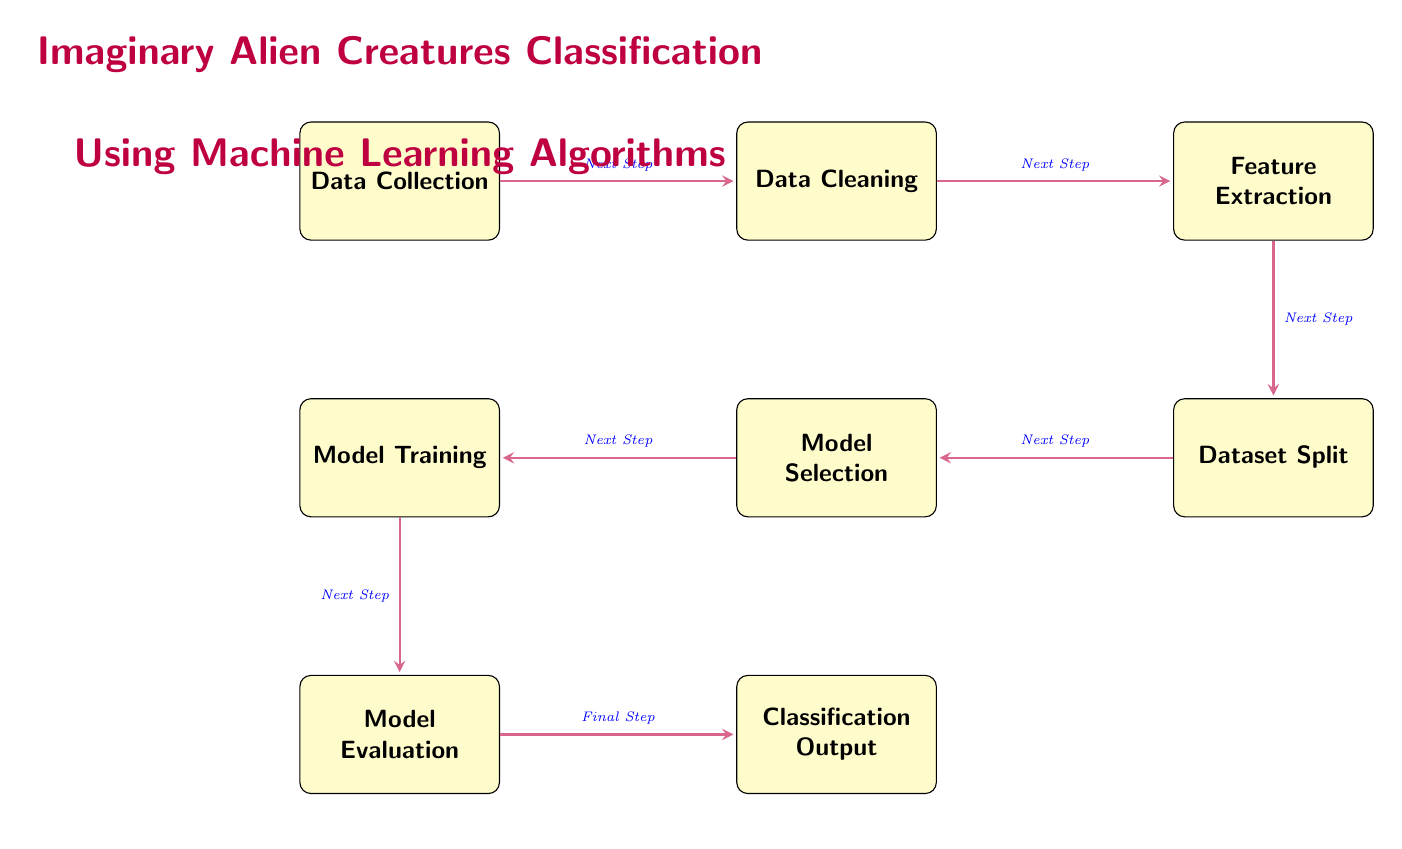What is the first step in the diagram? The first step in the diagram is labeled "Data Collection." It is positioned at the far left and shows the starting point of the process for classifying imaginary alien creatures.
Answer: Data Collection What node follows "Data Cleaning"? The node that follows "Data Cleaning" is "Feature Extraction." From the direction of the arrows in the diagram, it is clear that "Feature Extraction" comes right after "Data Cleaning."
Answer: Feature Extraction How many nodes are in the diagram? To find the number of nodes, we can count them: "Data Collection," "Data Cleaning," "Feature Extraction," "Dataset Split," "Model Selection," "Model Training," "Model Evaluation," and "Classification Output." There are eight nodes in total.
Answer: Eight What is the last step before the "Classification Output"? The last step before "Classification Output" is "Model Evaluation." This is indicated by the arrow leading directly to "Classification Output" from "Model Evaluation," completing the process.
Answer: Model Evaluation What does "Model Selection" involve? "Model Selection" involves choosing suitable ML algorithms like SVM or Random Forest. This specific information is captured in the description of that node, indicating it's an important consideration in the classification process.
Answer: Choose suitable ML algorithms like SVM or Random Forest What is the relationship between "Dataset Split" and "Model Training"? The relationship between "Dataset Split" and "Model Training" is sequential. "Dataset Split" is where the combined data is divided into training and test sets, which is essential before moving on to "Model Training." This makes it clear that "Model Training" relies on the output of "Dataset Split."
Answer: Sequential dependency What happens during "Feature Extraction"? During "Feature Extraction," features such as color, shape, and size are extracted from the alien creature data. This step is vital as it converts raw data into structured information useful for classification.
Answer: Extract features like color, shape, and size What overall goal does the diagram depict? The overall goal depicted in the diagram is "Imaginary Alien Creatures Classification." This is stated at the top and represents what all the steps aim to achieve, which is to classify various peculiar alien beings using the outlined machine learning methods.
Answer: Imaginary Alien Creatures Classification 